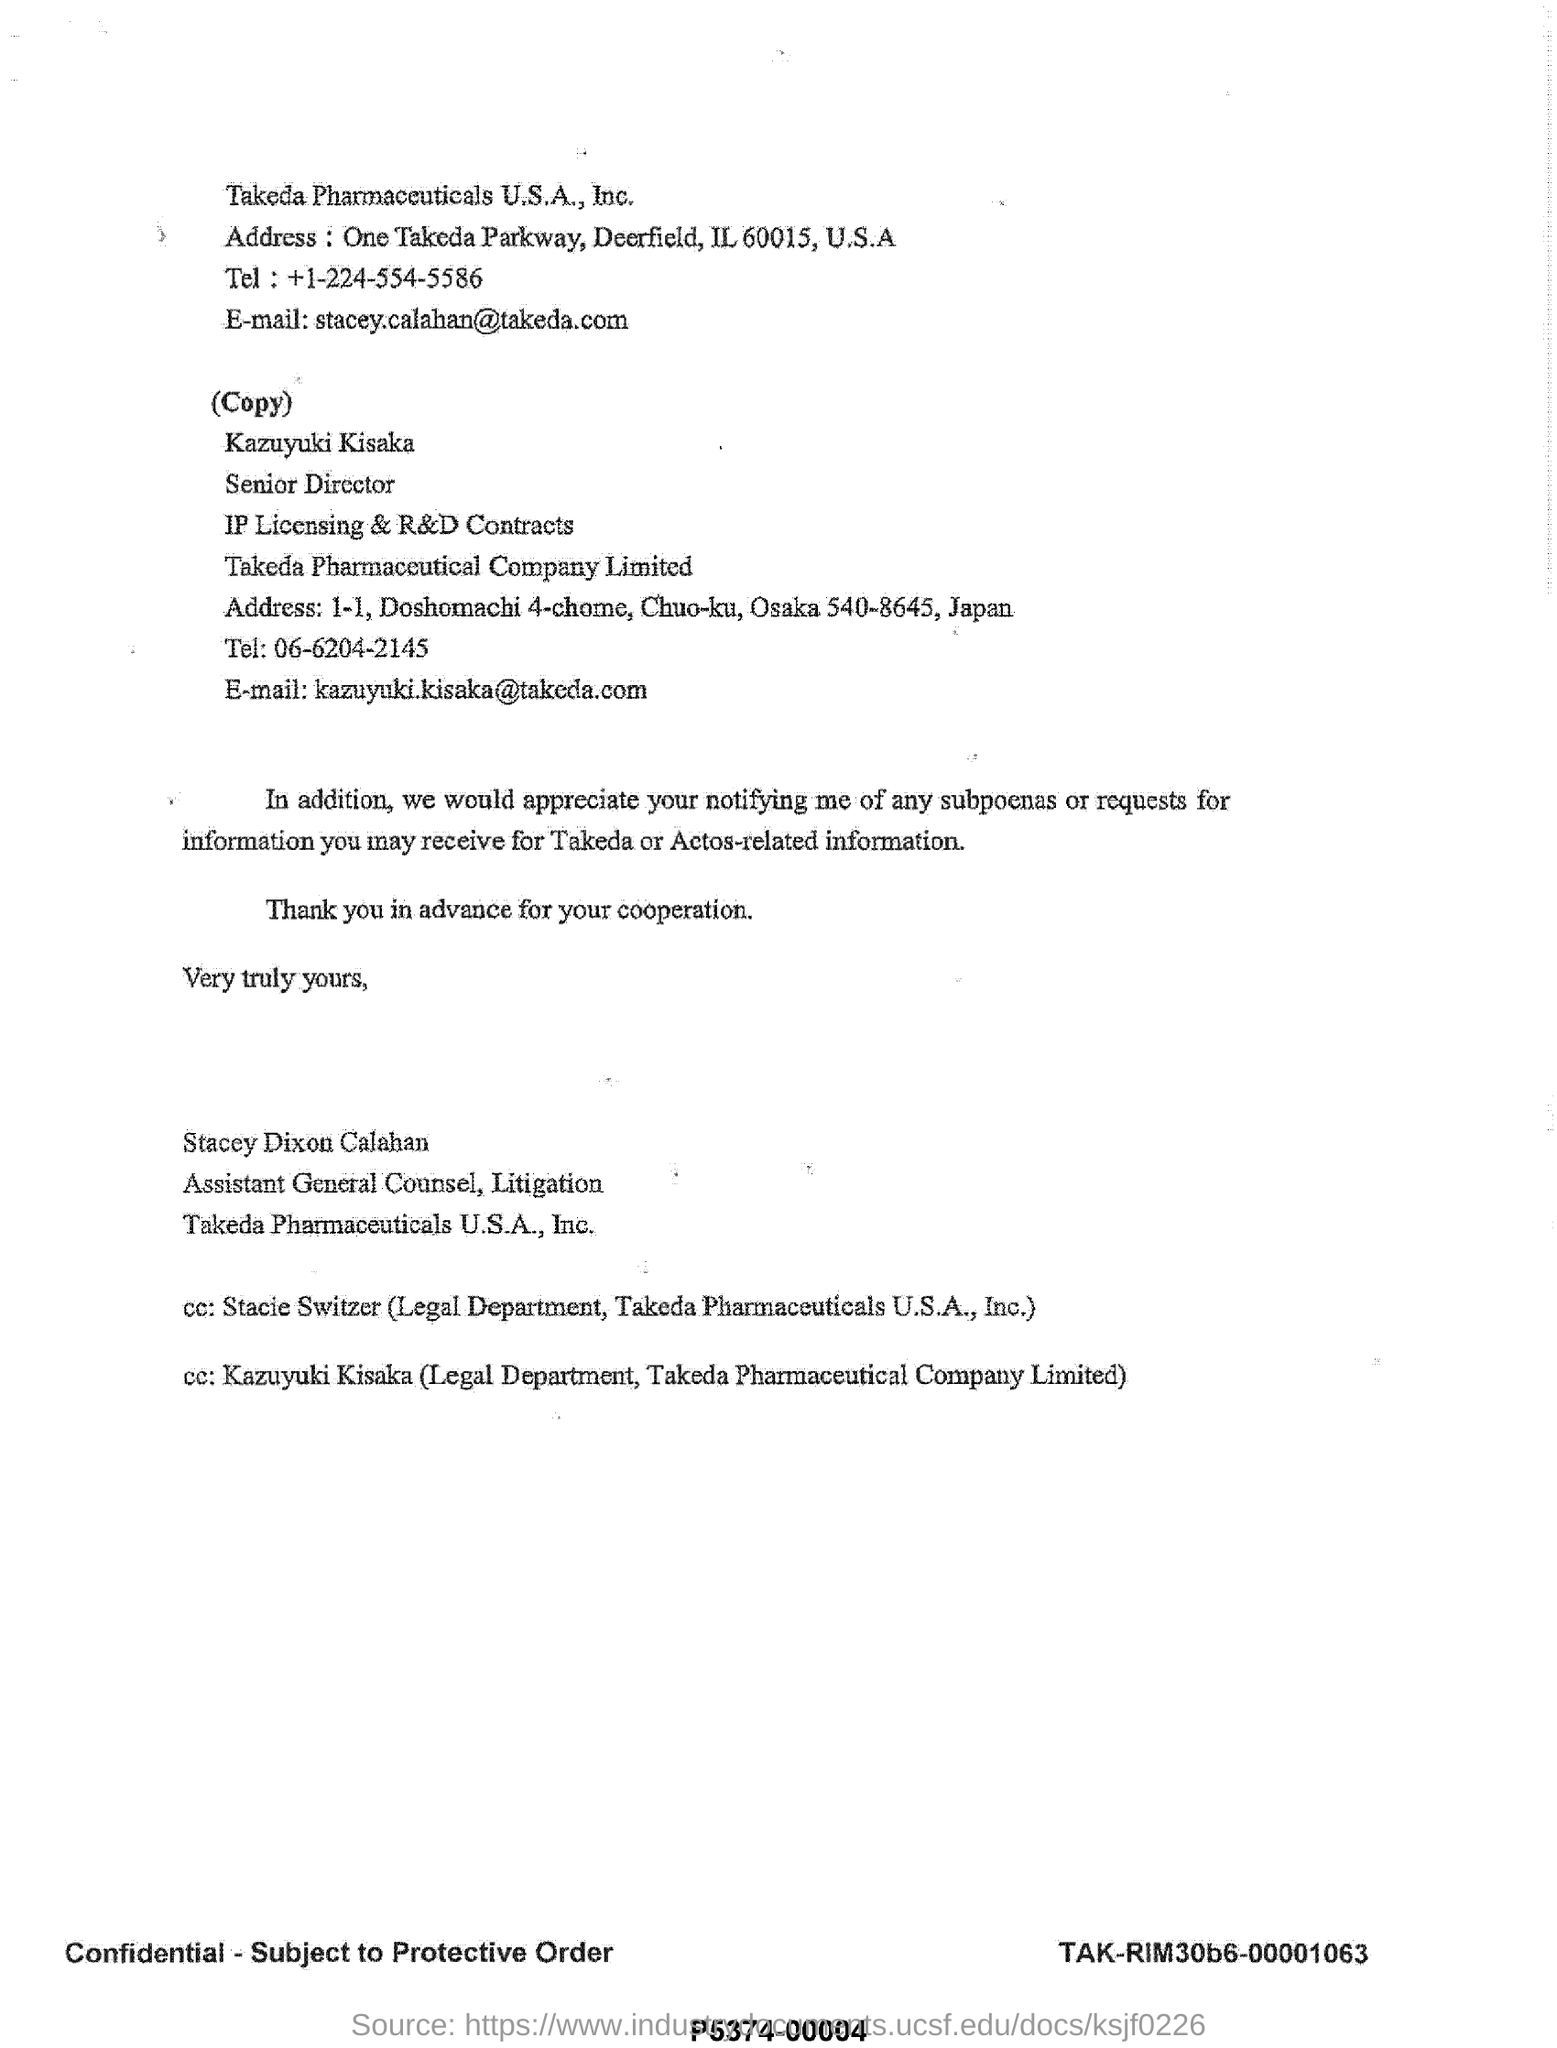By whom is this document written?
Give a very brief answer. Stacey Dixon Calahan. 